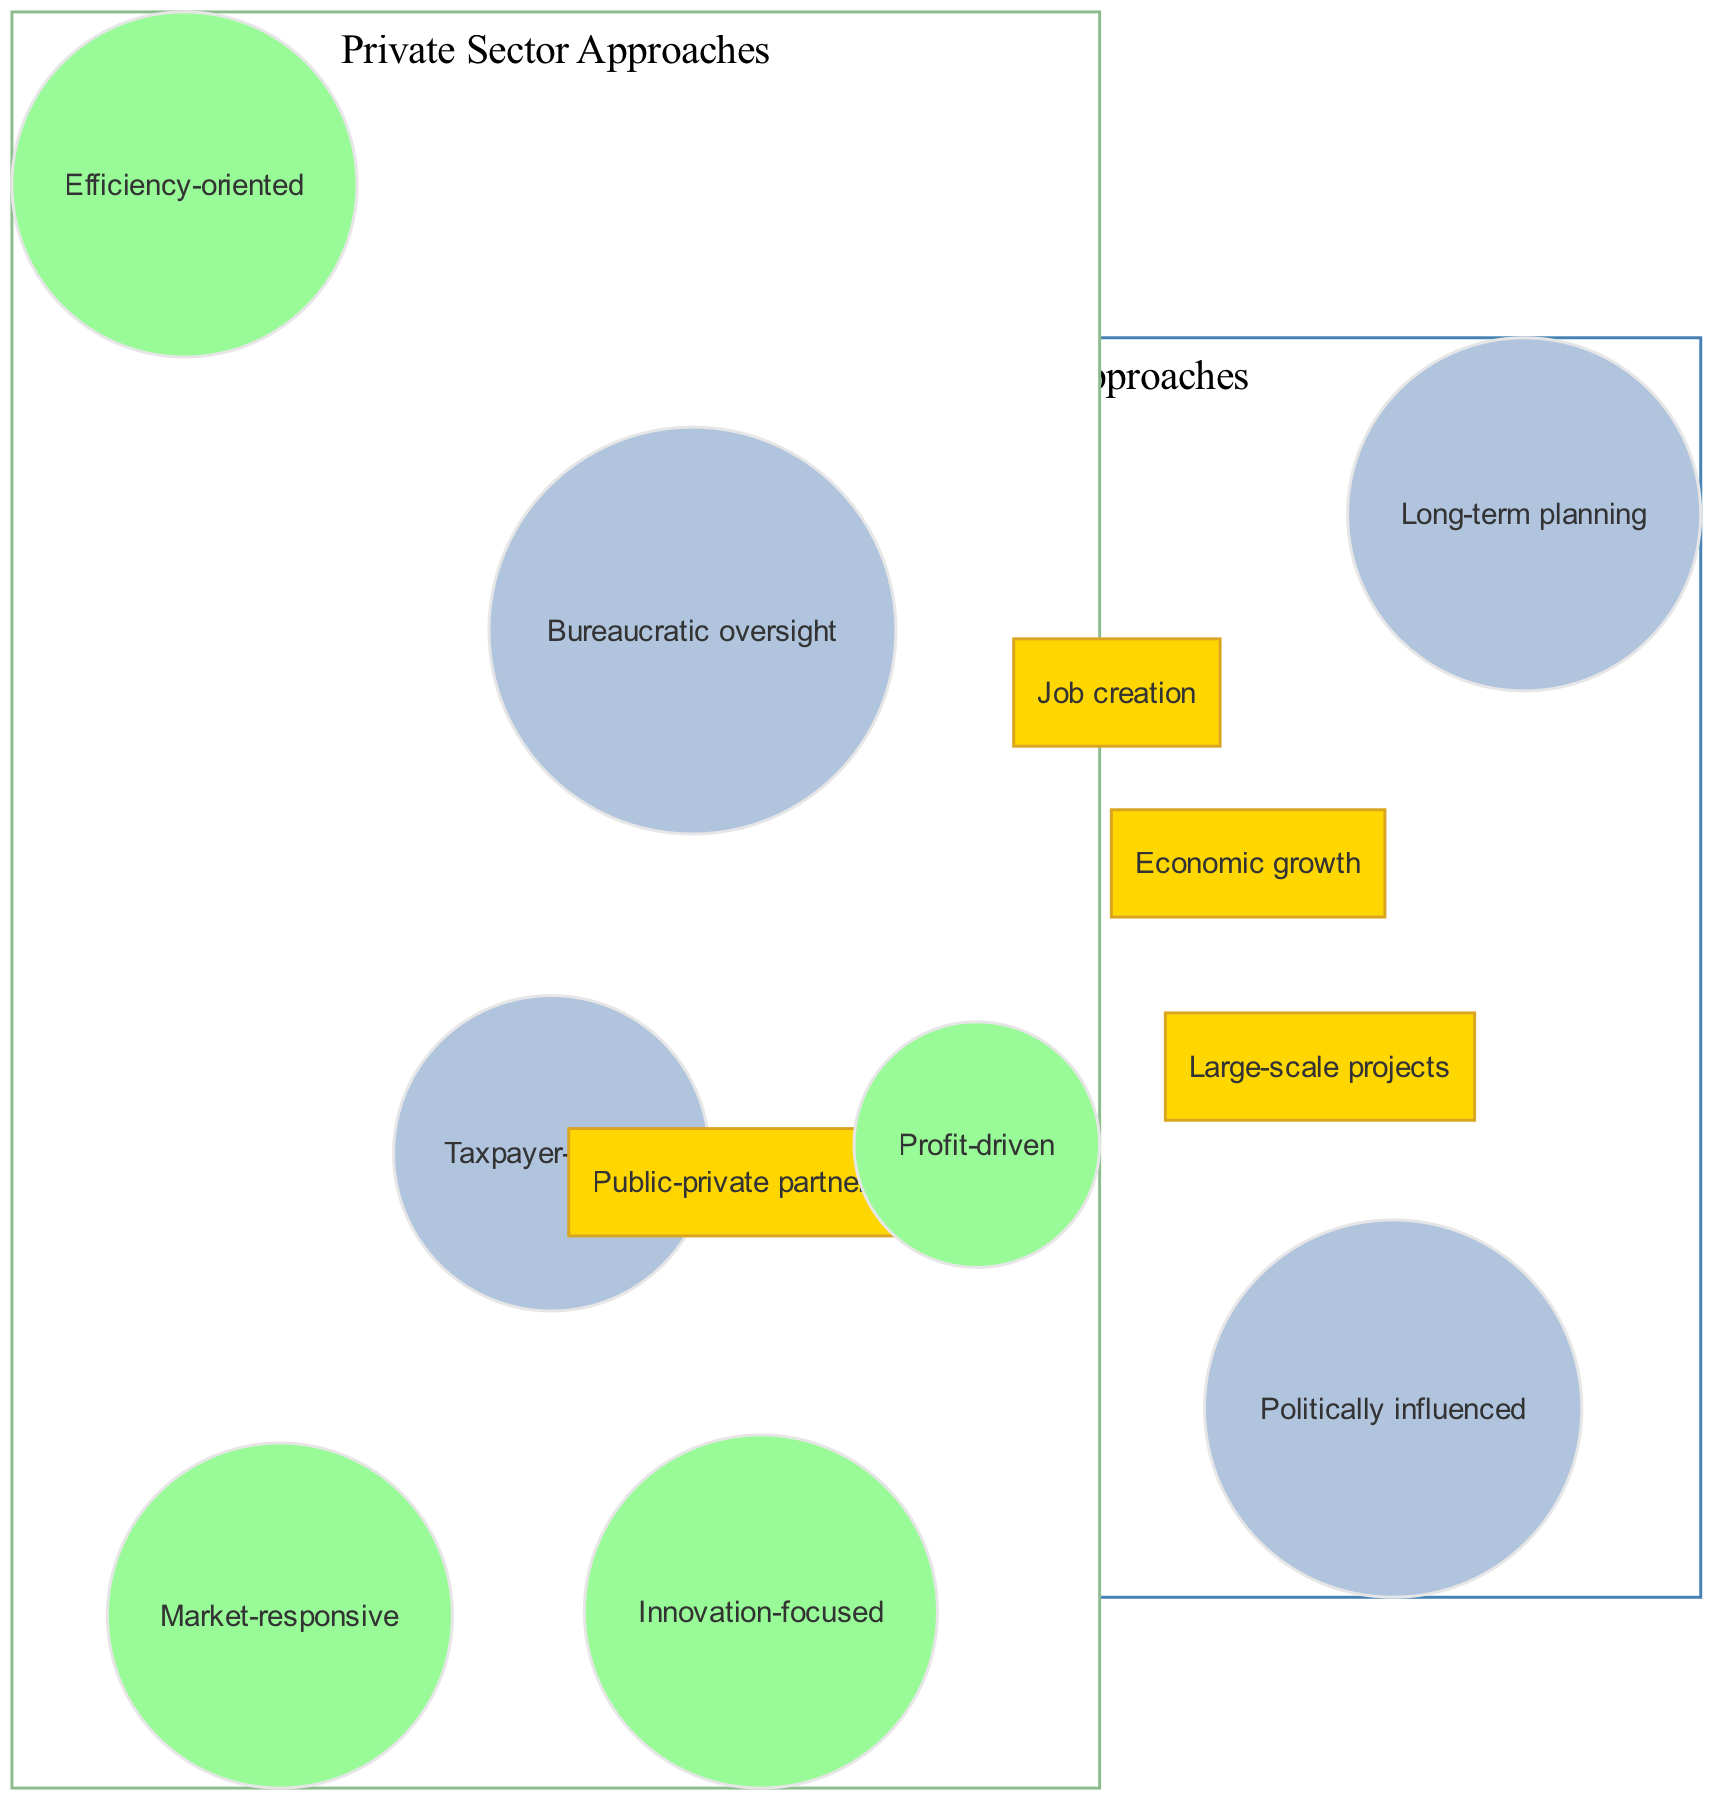What are the elements in the Government Approaches circle? The Government Approaches circle contains the elements: Taxpayer-funded, Bureaucratic oversight, Politically influenced, and Long-term planning. These can be directly identified within the section labeled "Government Approaches" in the diagram.
Answer: Taxpayer-funded, Bureaucratic oversight, Politically influenced, Long-term planning What is one element unique to the Private Sector Approaches? By examining the Private Sector Approaches circle, the unique elements are Profit-driven, Market-responsive, Innovation-focused, and Efficiency-oriented. One specific element that stands out is "Profit-driven," which is exclusive to this circle.
Answer: Profit-driven How many elements are in the overlap section? The overlap section includes the items: Public-private partnerships, Job creation, Economic growth, and Large-scale projects. Counting these reveals that there are four distinct items in the overlap area.
Answer: 4 What does the overlap represent between the two approaches? The overlap consists of items that signify areas where both government and private sector efforts collaborate or share common goals, such as Public-private partnerships and Economic growth. This indicates combined aims in infrastructure.
Answer: Collaboration What element in the overlap relates to both government and private sector approaches? In the overlap section, "Economic growth" is present, which relates to both Government Approaches and Private Sector Approaches as a shared objective for infrastructure improvements. It is a common goal reflected in both circles.
Answer: Economic growth What approach is characterized by long-term planning? "Long-term planning" is specifically listed within the Government Approaches circle, indicating that this method focuses on strategies and infrastructure developments over an extended time frame.
Answer: Government Approaches Which approach is described as innovation-focused? The phrase "Innovation-focused" is found in the Private Sector Approaches circle, which points to the private sector's emphasis on introducing new ideas and technologies in its infrastructure projects.
Answer: Private Sector Approaches What is an example of a shared benefit in the overlap? An example of a shared benefit found in the overlap is "Job creation," which illustrates that both government and private sector initiatives in infrastructure can lead to the generation of employment opportunities.
Answer: Job creation 